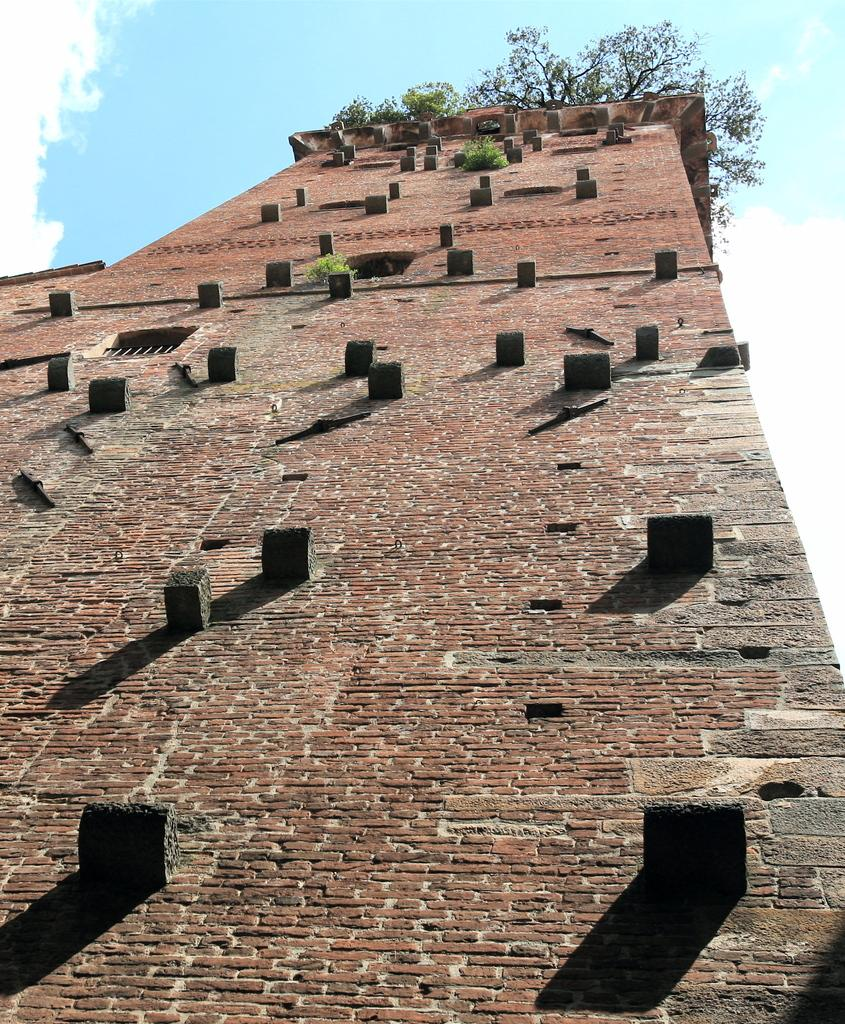What type of structure can be seen in the image? There is a brick wall and a building in the image. What architectural feature is present in the image? There is a window in the image. What type of vegetation is visible in the image? There are plants in the image. What is the color of the sky in the image? The sky is blue and white in color. How does the experience of washing the plants in the image compare to other experiences? There is no experience of washing the plants in the image, as it only shows a brick wall, a building, a window, plants, and a blue and white sky. 